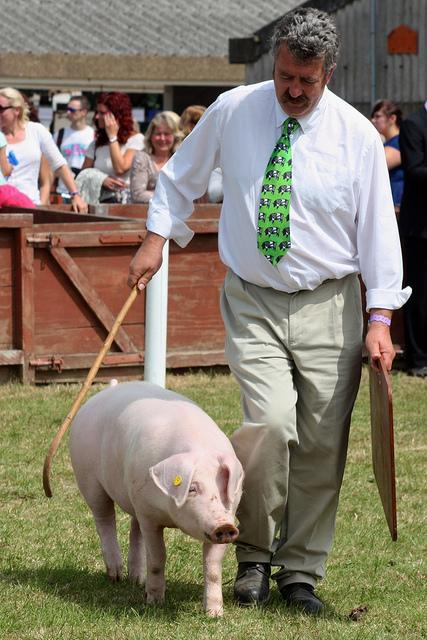What is the pig here entered in?

Choices:
A) show
B) race
C) roping contest
D) beauty contest show 